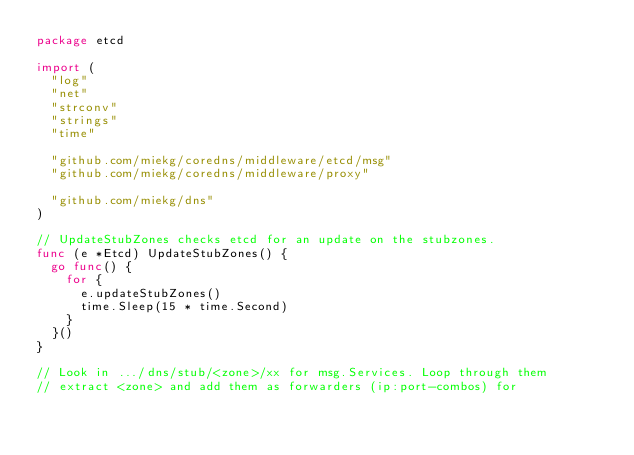<code> <loc_0><loc_0><loc_500><loc_500><_Go_>package etcd

import (
	"log"
	"net"
	"strconv"
	"strings"
	"time"

	"github.com/miekg/coredns/middleware/etcd/msg"
	"github.com/miekg/coredns/middleware/proxy"

	"github.com/miekg/dns"
)

// UpdateStubZones checks etcd for an update on the stubzones.
func (e *Etcd) UpdateStubZones() {
	go func() {
		for {
			e.updateStubZones()
			time.Sleep(15 * time.Second)
		}
	}()
}

// Look in .../dns/stub/<zone>/xx for msg.Services. Loop through them
// extract <zone> and add them as forwarders (ip:port-combos) for</code> 